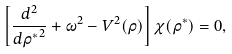<formula> <loc_0><loc_0><loc_500><loc_500>\left [ \frac { d ^ { 2 } } { { d { \rho } ^ { * } } ^ { 2 } } + \omega ^ { 2 } - { V } ^ { 2 } ( \rho ) \right ] \chi ( { \rho } ^ { * } ) = 0 ,</formula> 